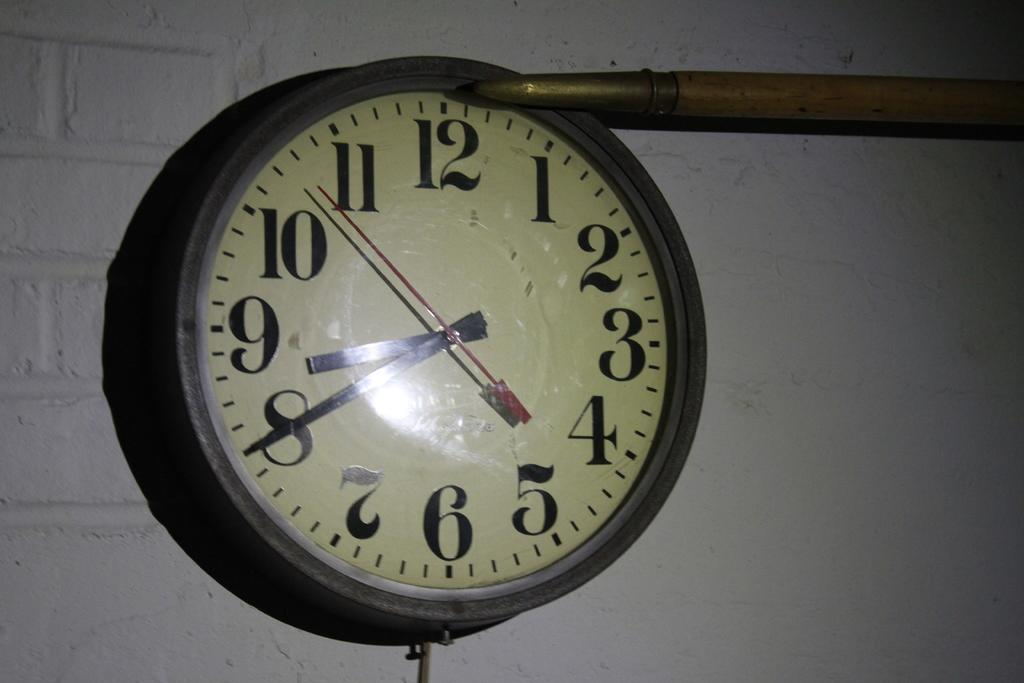<image>
Relay a brief, clear account of the picture shown. A large round clock that shows it to be twenty til nine. 